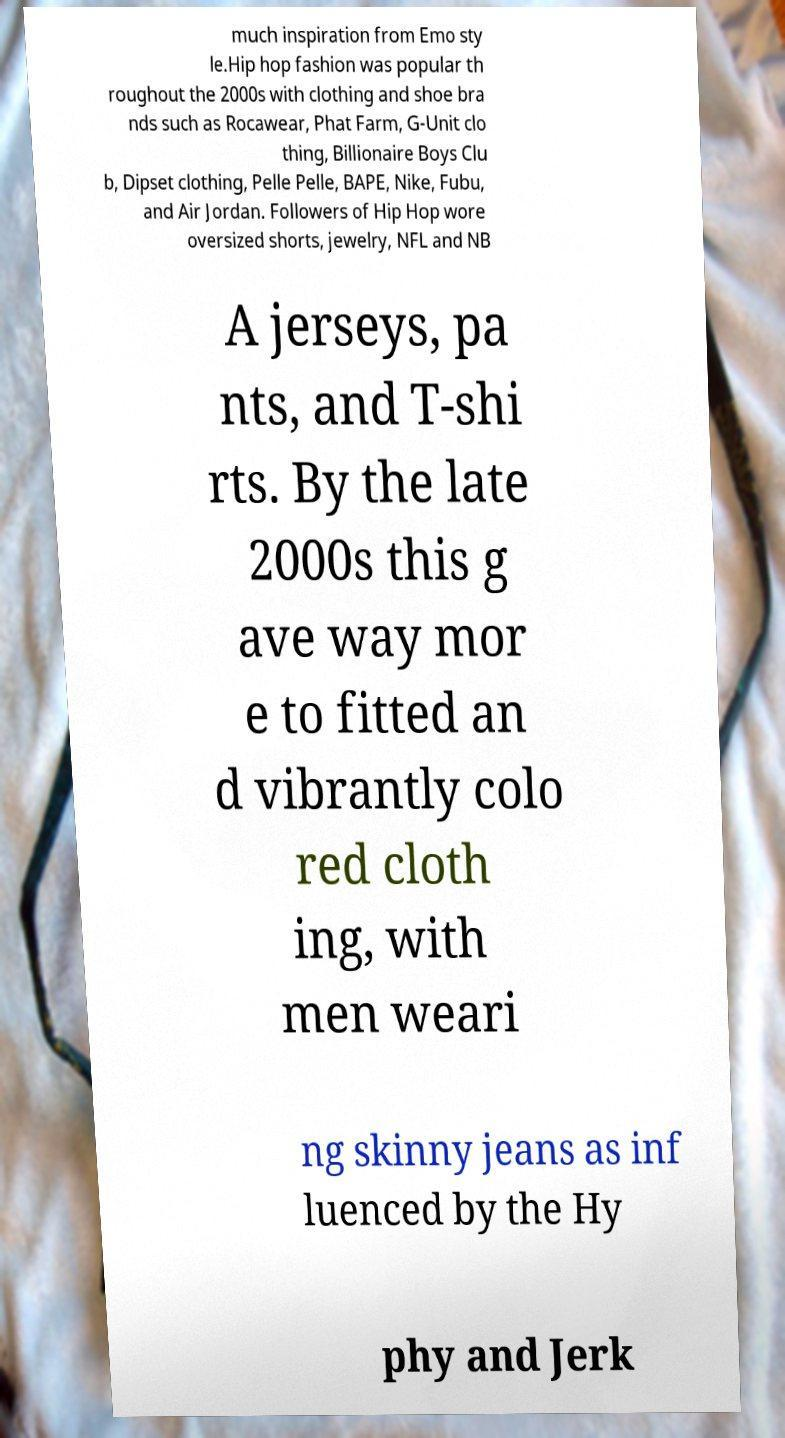I need the written content from this picture converted into text. Can you do that? much inspiration from Emo sty le.Hip hop fashion was popular th roughout the 2000s with clothing and shoe bra nds such as Rocawear, Phat Farm, G-Unit clo thing, Billionaire Boys Clu b, Dipset clothing, Pelle Pelle, BAPE, Nike, Fubu, and Air Jordan. Followers of Hip Hop wore oversized shorts, jewelry, NFL and NB A jerseys, pa nts, and T-shi rts. By the late 2000s this g ave way mor e to fitted an d vibrantly colo red cloth ing, with men weari ng skinny jeans as inf luenced by the Hy phy and Jerk 